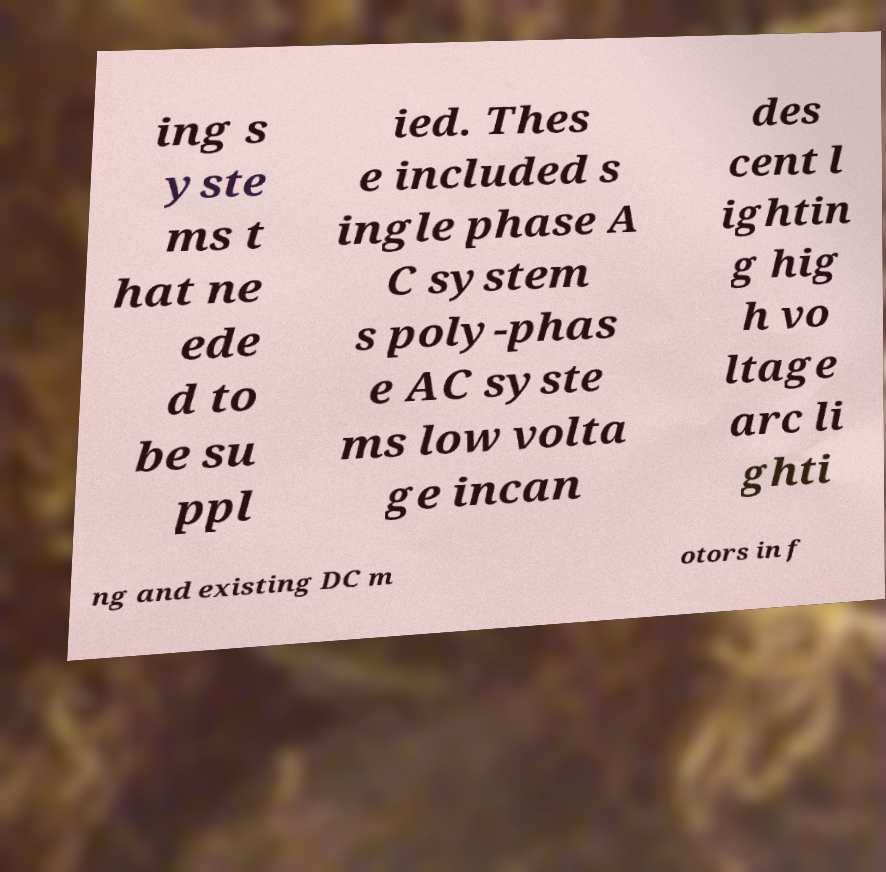Could you extract and type out the text from this image? ing s yste ms t hat ne ede d to be su ppl ied. Thes e included s ingle phase A C system s poly-phas e AC syste ms low volta ge incan des cent l ightin g hig h vo ltage arc li ghti ng and existing DC m otors in f 